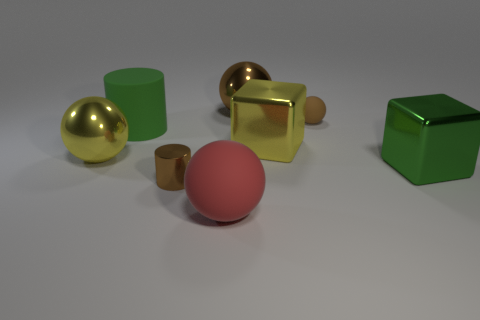Is the number of green metal blocks that are in front of the large yellow metal block greater than the number of metallic cylinders that are to the left of the green matte thing?
Make the answer very short. Yes. What number of large things are on the right side of the large metallic thing on the right side of the tiny brown matte ball?
Your answer should be compact. 0. Are there any balls of the same color as the tiny cylinder?
Offer a terse response. Yes. Is the green cylinder the same size as the red thing?
Offer a terse response. Yes. Is the color of the small ball the same as the small metal thing?
Offer a very short reply. Yes. What is the large red ball that is left of the rubber object that is to the right of the big brown thing made of?
Your answer should be very brief. Rubber. There is a small brown thing that is the same shape as the large red thing; what is its material?
Provide a succinct answer. Rubber. Does the yellow thing that is right of the brown metallic sphere have the same size as the tiny brown rubber sphere?
Keep it short and to the point. No. What number of rubber things are cylinders or large red objects?
Your answer should be very brief. 2. What is the material of the thing that is right of the yellow metallic cube and behind the big yellow block?
Provide a succinct answer. Rubber. 